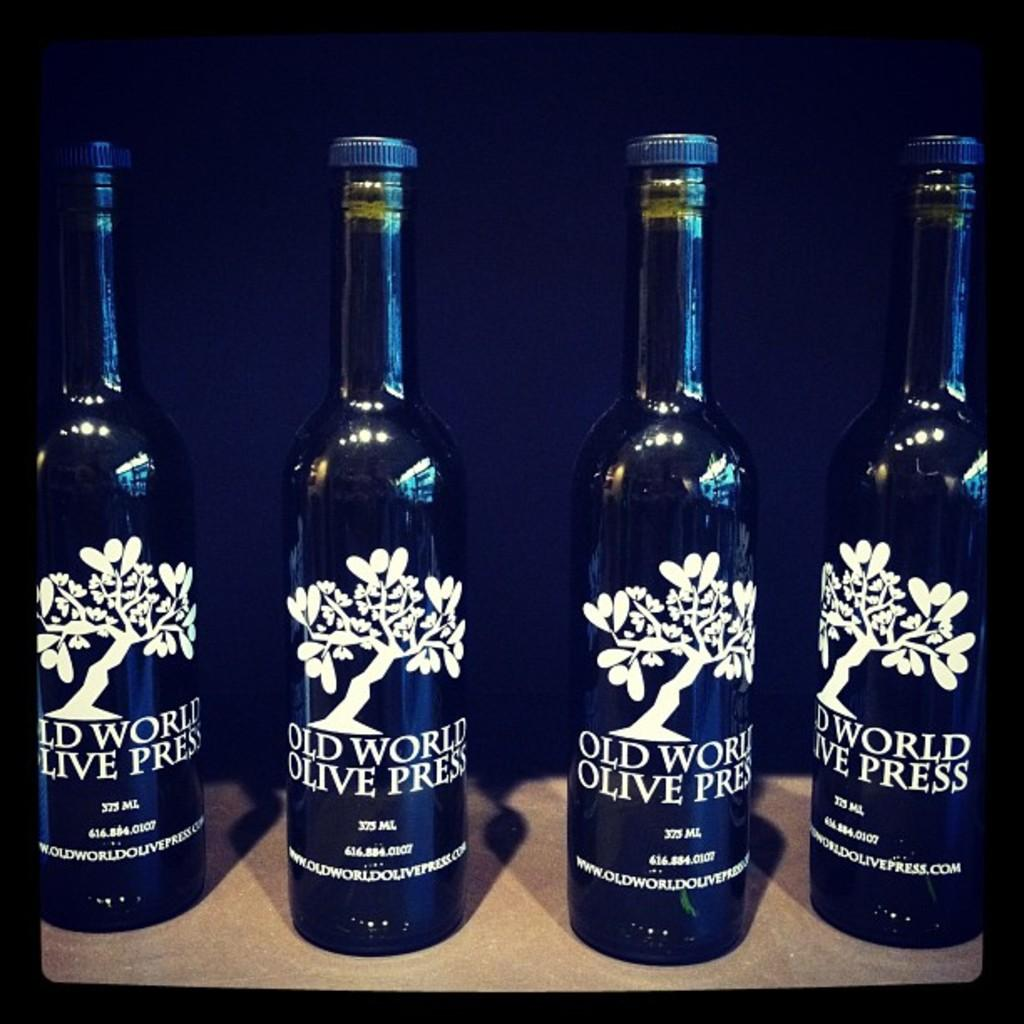Provide a one-sentence caption for the provided image. Four bottles of Old World Olive Press are displayed. 